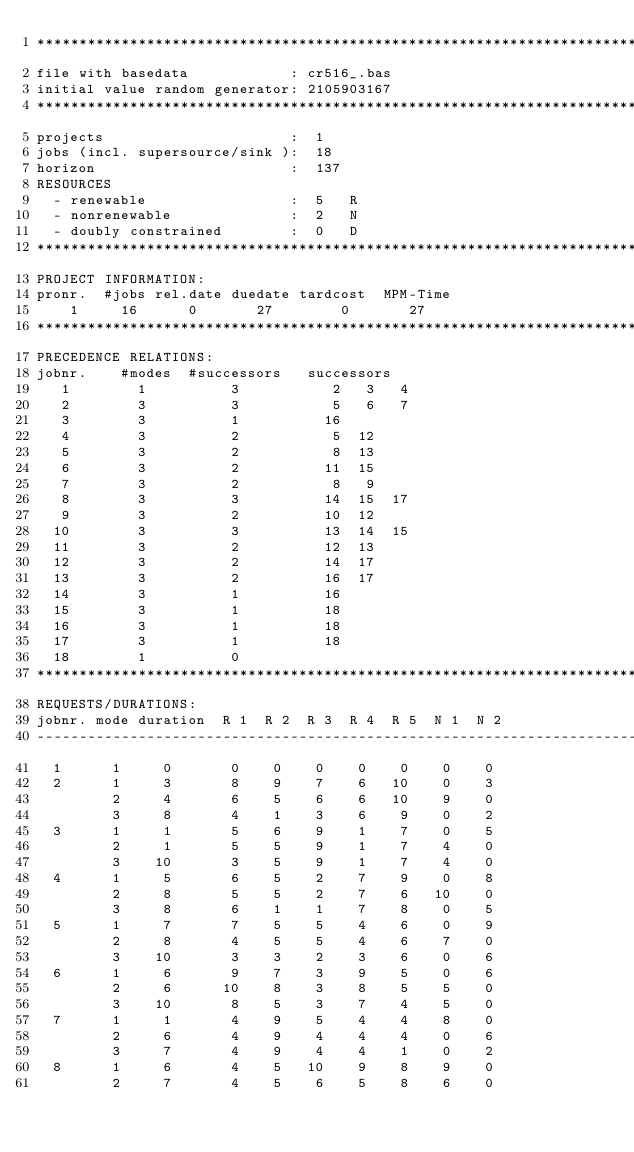<code> <loc_0><loc_0><loc_500><loc_500><_ObjectiveC_>************************************************************************
file with basedata            : cr516_.bas
initial value random generator: 2105903167
************************************************************************
projects                      :  1
jobs (incl. supersource/sink ):  18
horizon                       :  137
RESOURCES
  - renewable                 :  5   R
  - nonrenewable              :  2   N
  - doubly constrained        :  0   D
************************************************************************
PROJECT INFORMATION:
pronr.  #jobs rel.date duedate tardcost  MPM-Time
    1     16      0       27        0       27
************************************************************************
PRECEDENCE RELATIONS:
jobnr.    #modes  #successors   successors
   1        1          3           2   3   4
   2        3          3           5   6   7
   3        3          1          16
   4        3          2           5  12
   5        3          2           8  13
   6        3          2          11  15
   7        3          2           8   9
   8        3          3          14  15  17
   9        3          2          10  12
  10        3          3          13  14  15
  11        3          2          12  13
  12        3          2          14  17
  13        3          2          16  17
  14        3          1          16
  15        3          1          18
  16        3          1          18
  17        3          1          18
  18        1          0        
************************************************************************
REQUESTS/DURATIONS:
jobnr. mode duration  R 1  R 2  R 3  R 4  R 5  N 1  N 2
------------------------------------------------------------------------
  1      1     0       0    0    0    0    0    0    0
  2      1     3       8    9    7    6   10    0    3
         2     4       6    5    6    6   10    9    0
         3     8       4    1    3    6    9    0    2
  3      1     1       5    6    9    1    7    0    5
         2     1       5    5    9    1    7    4    0
         3    10       3    5    9    1    7    4    0
  4      1     5       6    5    2    7    9    0    8
         2     8       5    5    2    7    6   10    0
         3     8       6    1    1    7    8    0    5
  5      1     7       7    5    5    4    6    0    9
         2     8       4    5    5    4    6    7    0
         3    10       3    3    2    3    6    0    6
  6      1     6       9    7    3    9    5    0    6
         2     6      10    8    3    8    5    5    0
         3    10       8    5    3    7    4    5    0
  7      1     1       4    9    5    4    4    8    0
         2     6       4    9    4    4    4    0    6
         3     7       4    9    4    4    1    0    2
  8      1     6       4    5   10    9    8    9    0
         2     7       4    5    6    5    8    6    0</code> 